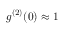Convert formula to latex. <formula><loc_0><loc_0><loc_500><loc_500>g ^ { ( 2 ) } ( 0 ) \approx 1</formula> 